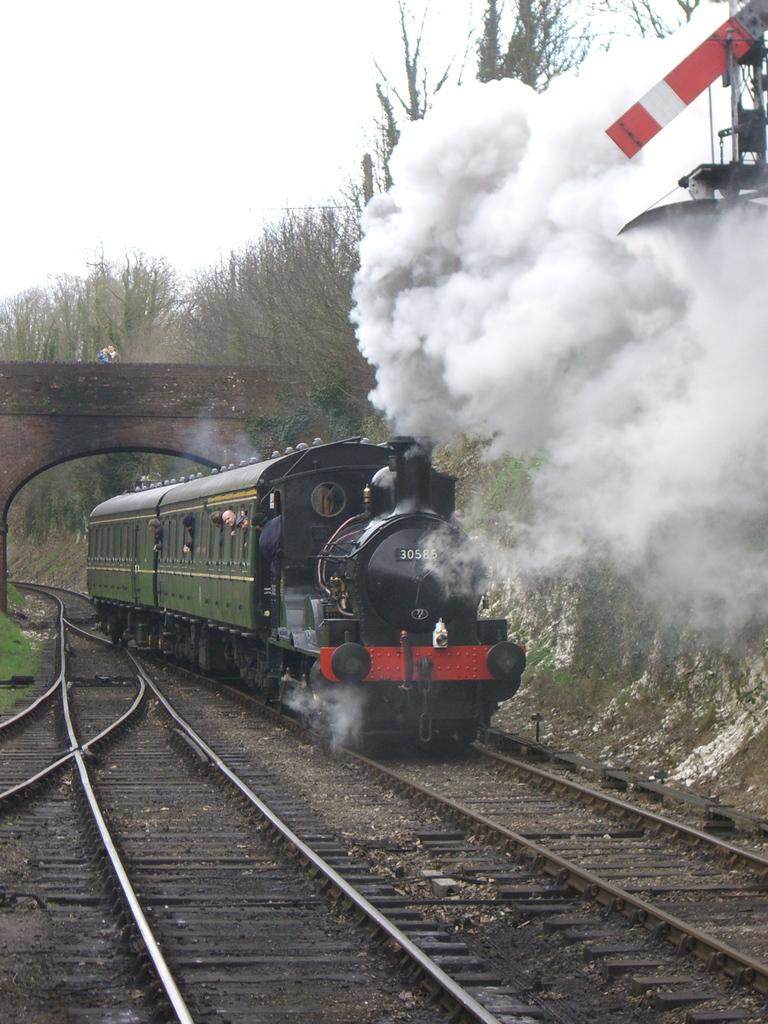What is the main subject of the image? The main subject of the image is a railway track and a train. What is the train doing in the image? The train is on the railway track. What can be seen coming out of the train in the image? Smoke is visible in the image. What type of natural environment is visible in the image? There are trees in the image. What is visible in the background of the image? The sky is visible in the image. What type of writing can be seen on the train in the image? There is no writing visible on the train in the image. What type of business is being conducted in the image? There is no indication of any business being conducted in the image. 